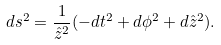Convert formula to latex. <formula><loc_0><loc_0><loc_500><loc_500>d s ^ { 2 } = \frac { 1 } { \hat { z } ^ { 2 } } ( - d t ^ { 2 } + d \phi ^ { 2 } + d \hat { z } ^ { 2 } ) .</formula> 